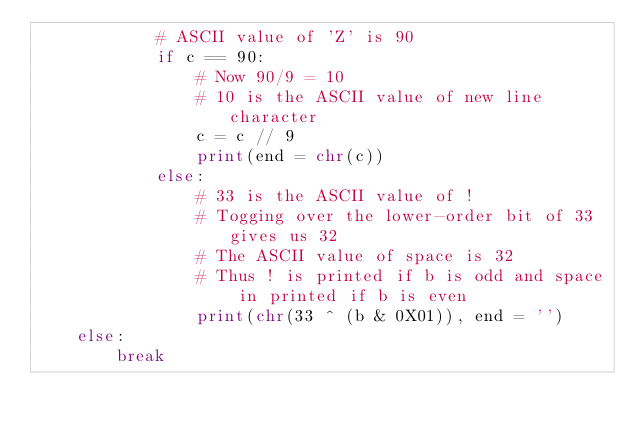Convert code to text. <code><loc_0><loc_0><loc_500><loc_500><_Python_>            # ASCII value of 'Z' is 90  
            if c == 90:
                # Now 90/9 = 10
                # 10 is the ASCII value of new line character  
                c = c // 9
                print(end = chr(c))  
            else:
                # 33 is the ASCII value of !
                # Togging over the lower-order bit of 33 gives us 32
                # The ASCII value of space is 32
                # Thus ! is printed if b is odd and space in printed if b is even   
                print(chr(33 ^ (b & 0X01)), end = '')  
    else:  
        break</code> 